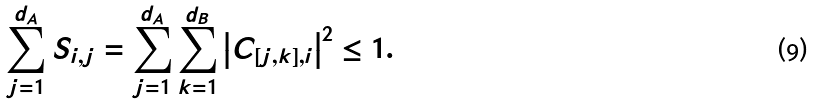<formula> <loc_0><loc_0><loc_500><loc_500>\sum _ { j = 1 } ^ { d _ { A } } S _ { i , j } = \sum _ { j = 1 } ^ { d _ { A } } \sum _ { k = 1 } ^ { d _ { B } } \left | C _ { [ j , k ] , i } \right | ^ { 2 } \leq 1 .</formula> 